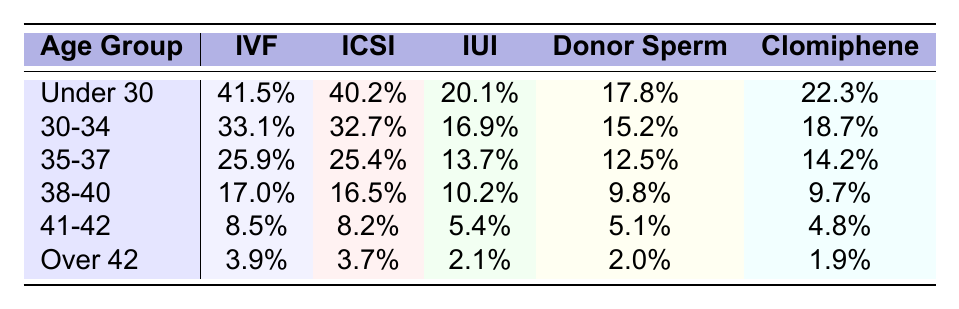What is the IVF success rate for the age group 30-34? The table shows the IVF success rate for the age group 30-34 as 33.1%.
Answer: 33.1% Which age group has the highest success rate for IUI? By looking at the IUI success rates, the age group Under 30 has the highest rate at 20.1%.
Answer: Under 30 What is the difference in IVF success rates between the age groups 35-37 and 38-40? The IVF success rate for 35-37 is 25.9% and for 38-40 is 17.0%. The difference is 25.9% - 17.0% = 8.9%.
Answer: 8.9% Is the success rate for Clomiphene Citrate higher in the age group 30-34 or 35-37? The Clomiphene Citrate success rate for 30-34 is 18.7%, while for 35-37 it is 14.2%. Therefore, it is higher in 30-34.
Answer: Yes What is the average IVF success rate across all age groups? The IVF success rates are: 41.5%, 33.1%, 25.9%, 17.0%, 8.5%, and 3.9%. Adding them up gives a total of 129.9%. Dividing by the number of age groups (6) gives an average of 21.65%.
Answer: 21.65% Among all treatments, which one has the lowest success rate for the age group Over 42? For the age group Over 42, the success rates are as follows: IVF 3.9%, ICSI 3.7%, IUI 2.1%, Donor Sperm 2.0%, and Clomiphene 1.9%. Clomiphene has the lowest success rate at 1.9%.
Answer: Clomiphene Citrate Which fertility treatment consistently has the lowest success rates across all age groups? Reviewing all the success rates across age groups, Clomiphene Citrate has the lowest success rates consistently when compared with the others.
Answer: Clomiphene Citrate What is the trend in IVF success rates as the age group increases? By observing the IVF success rates for each age group, it decreases as the age group increases: 41.5% (Under 30) to 3.9% (Over 42). This indicates a downward trend.
Answer: Decreasing trend How much higher is the success rate for Donor Sperm in the age group 30-34 compared to the age group 41-42? The Donor Sperm success rate for 30-34 is 15.2% and for 41-42 it is 5.1%. The difference is 15.2% - 5.1% = 10.1%.
Answer: 10.1% Which treatment method has the largest decline in success rate from the age group Under 30 to Over 42? Checking the change in success rates, for IVF it drops from 41.5% to 3.9% (37.6% decline), for IUI from 20.1% to 2.1% (18% decline), and for Clomiphene from 22.3% to 1.9% (20.4% decline). The largest decline is in IVF.
Answer: IVF 